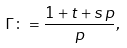<formula> <loc_0><loc_0><loc_500><loc_500>\Gamma \colon = \frac { 1 + t + s \, p } { p } ,</formula> 